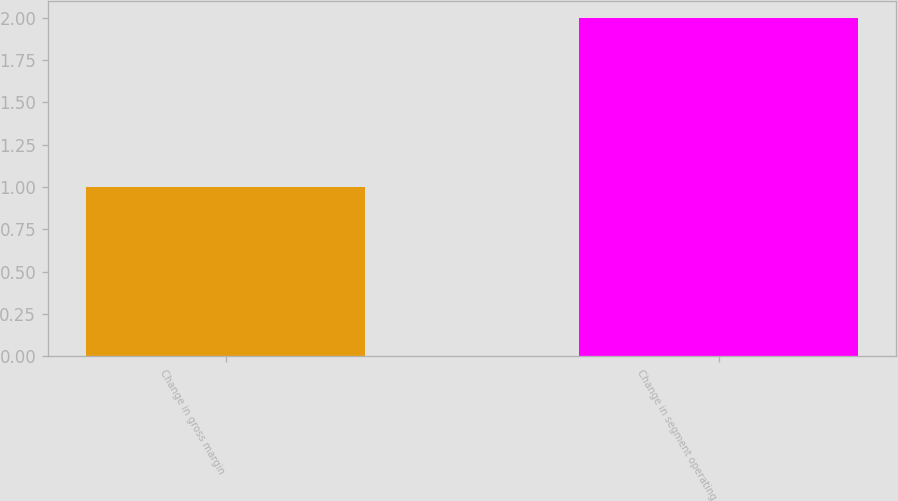<chart> <loc_0><loc_0><loc_500><loc_500><bar_chart><fcel>Change in gross margin<fcel>Change in segment operating<nl><fcel>1<fcel>2<nl></chart> 